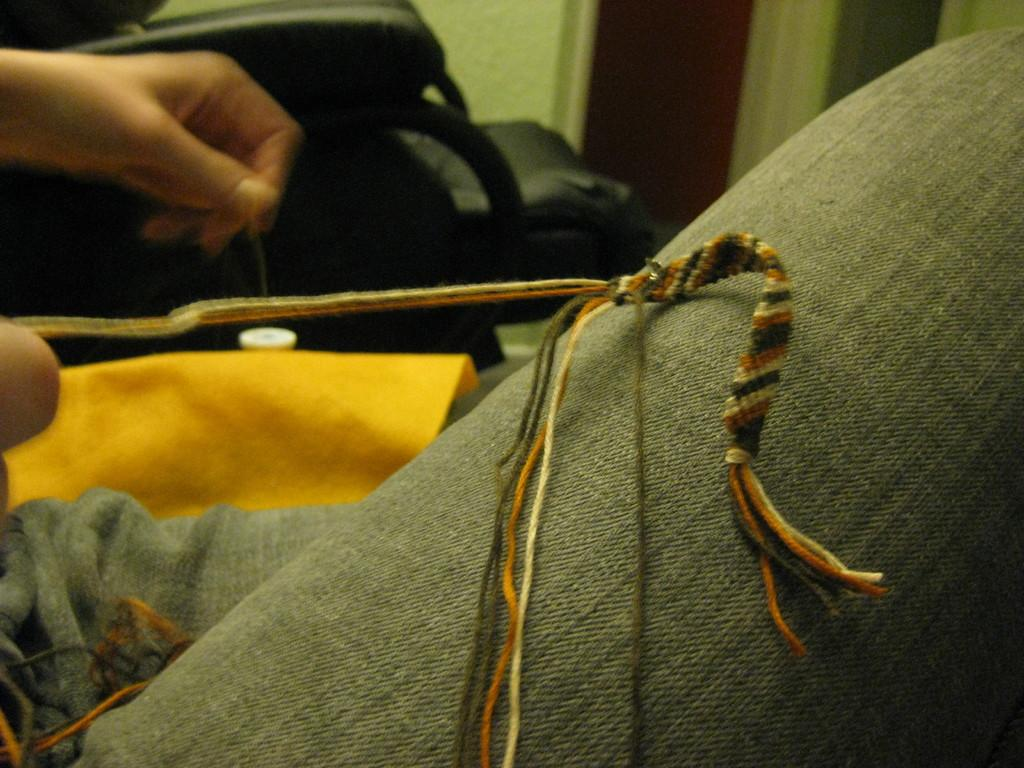What is the main focus of the image in the foreground? There is a person's leg in the foreground of the image. What is placed on the leg? A thread structure is placed on the leg. What can be seen in the background of the image? There is a chair, a wall, a door, and a person's hand visible in the background of the image. What type of sticks are used to make the oatmeal in the image? There is no oatmeal or sticks present in the image. How much salt is sprinkled on the person's leg in the image? There is no salt present in the image. 